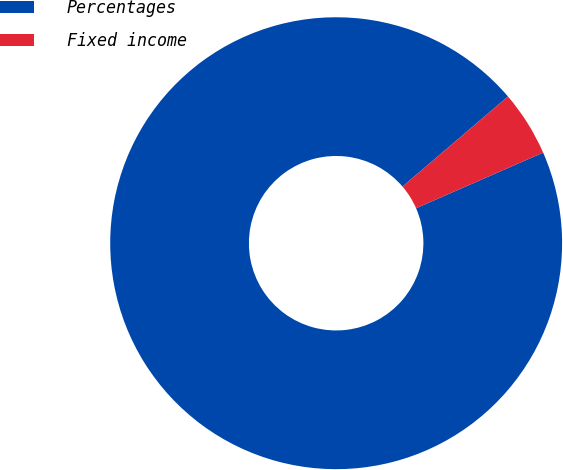Convert chart. <chart><loc_0><loc_0><loc_500><loc_500><pie_chart><fcel>Percentages<fcel>Fixed income<nl><fcel>95.32%<fcel>4.68%<nl></chart> 